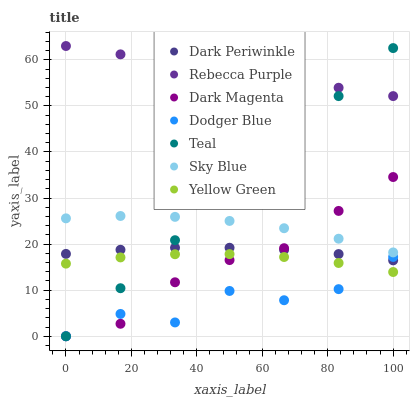Does Dodger Blue have the minimum area under the curve?
Answer yes or no. Yes. Does Rebecca Purple have the maximum area under the curve?
Answer yes or no. Yes. Does Rebecca Purple have the minimum area under the curve?
Answer yes or no. No. Does Dodger Blue have the maximum area under the curve?
Answer yes or no. No. Is Teal the smoothest?
Answer yes or no. Yes. Is Dodger Blue the roughest?
Answer yes or no. Yes. Is Rebecca Purple the smoothest?
Answer yes or no. No. Is Rebecca Purple the roughest?
Answer yes or no. No. Does Dark Magenta have the lowest value?
Answer yes or no. Yes. Does Rebecca Purple have the lowest value?
Answer yes or no. No. Does Rebecca Purple have the highest value?
Answer yes or no. Yes. Does Dodger Blue have the highest value?
Answer yes or no. No. Is Dodger Blue less than Rebecca Purple?
Answer yes or no. Yes. Is Rebecca Purple greater than Yellow Green?
Answer yes or no. Yes. Does Dodger Blue intersect Teal?
Answer yes or no. Yes. Is Dodger Blue less than Teal?
Answer yes or no. No. Is Dodger Blue greater than Teal?
Answer yes or no. No. Does Dodger Blue intersect Rebecca Purple?
Answer yes or no. No. 